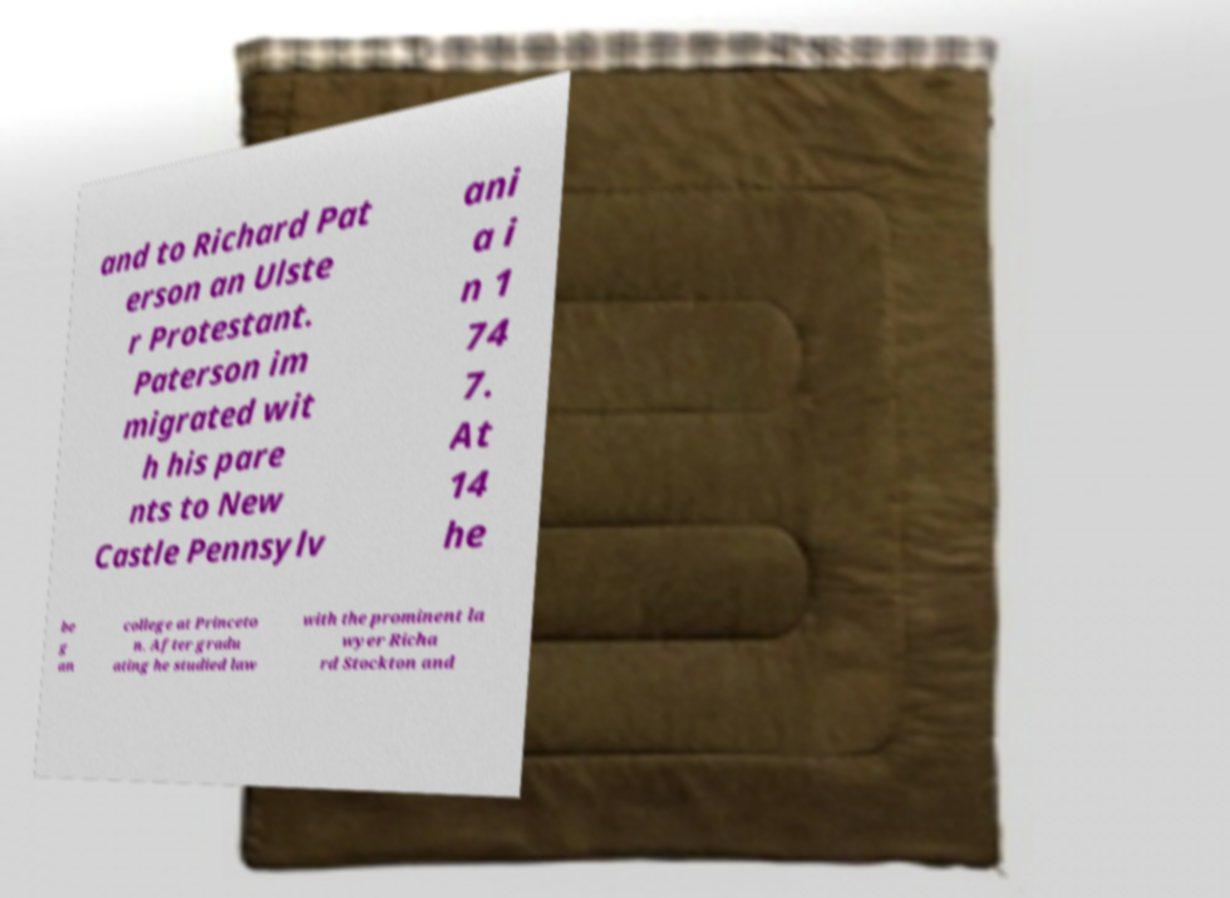Please read and relay the text visible in this image. What does it say? and to Richard Pat erson an Ulste r Protestant. Paterson im migrated wit h his pare nts to New Castle Pennsylv ani a i n 1 74 7. At 14 he be g an college at Princeto n. After gradu ating he studied law with the prominent la wyer Richa rd Stockton and 